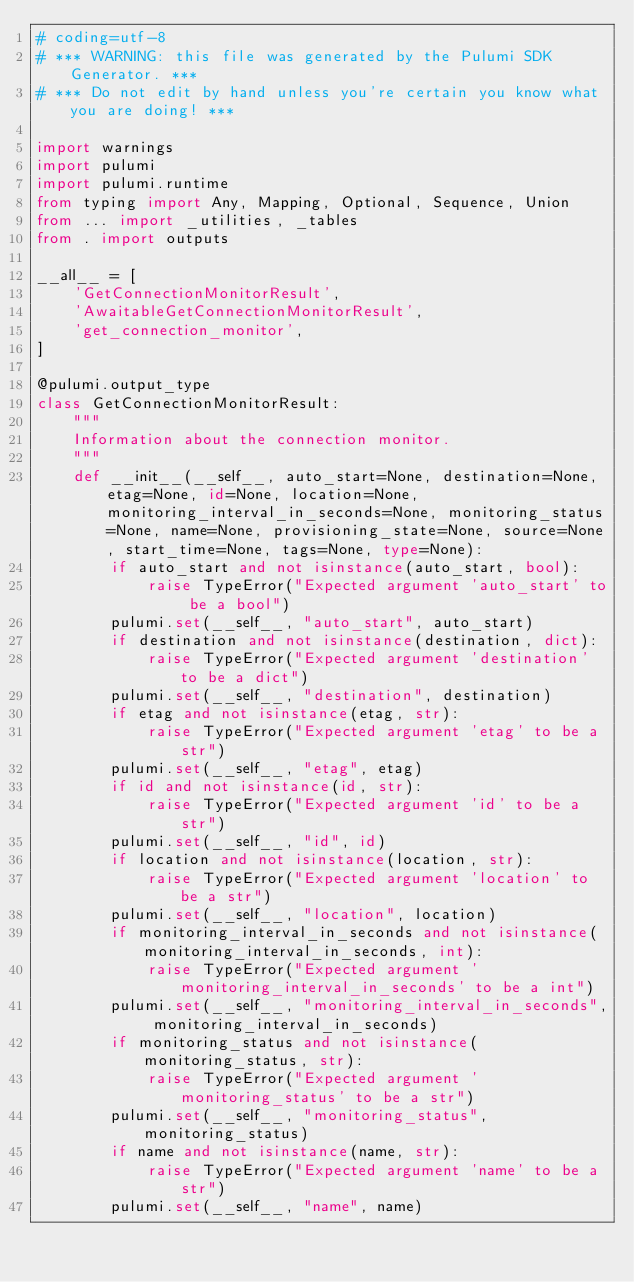Convert code to text. <code><loc_0><loc_0><loc_500><loc_500><_Python_># coding=utf-8
# *** WARNING: this file was generated by the Pulumi SDK Generator. ***
# *** Do not edit by hand unless you're certain you know what you are doing! ***

import warnings
import pulumi
import pulumi.runtime
from typing import Any, Mapping, Optional, Sequence, Union
from ... import _utilities, _tables
from . import outputs

__all__ = [
    'GetConnectionMonitorResult',
    'AwaitableGetConnectionMonitorResult',
    'get_connection_monitor',
]

@pulumi.output_type
class GetConnectionMonitorResult:
    """
    Information about the connection monitor.
    """
    def __init__(__self__, auto_start=None, destination=None, etag=None, id=None, location=None, monitoring_interval_in_seconds=None, monitoring_status=None, name=None, provisioning_state=None, source=None, start_time=None, tags=None, type=None):
        if auto_start and not isinstance(auto_start, bool):
            raise TypeError("Expected argument 'auto_start' to be a bool")
        pulumi.set(__self__, "auto_start", auto_start)
        if destination and not isinstance(destination, dict):
            raise TypeError("Expected argument 'destination' to be a dict")
        pulumi.set(__self__, "destination", destination)
        if etag and not isinstance(etag, str):
            raise TypeError("Expected argument 'etag' to be a str")
        pulumi.set(__self__, "etag", etag)
        if id and not isinstance(id, str):
            raise TypeError("Expected argument 'id' to be a str")
        pulumi.set(__self__, "id", id)
        if location and not isinstance(location, str):
            raise TypeError("Expected argument 'location' to be a str")
        pulumi.set(__self__, "location", location)
        if monitoring_interval_in_seconds and not isinstance(monitoring_interval_in_seconds, int):
            raise TypeError("Expected argument 'monitoring_interval_in_seconds' to be a int")
        pulumi.set(__self__, "monitoring_interval_in_seconds", monitoring_interval_in_seconds)
        if monitoring_status and not isinstance(monitoring_status, str):
            raise TypeError("Expected argument 'monitoring_status' to be a str")
        pulumi.set(__self__, "monitoring_status", monitoring_status)
        if name and not isinstance(name, str):
            raise TypeError("Expected argument 'name' to be a str")
        pulumi.set(__self__, "name", name)</code> 